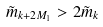Convert formula to latex. <formula><loc_0><loc_0><loc_500><loc_500>\tilde { m } _ { k + 2 M _ { 1 } } > 2 \tilde { m } _ { k }</formula> 